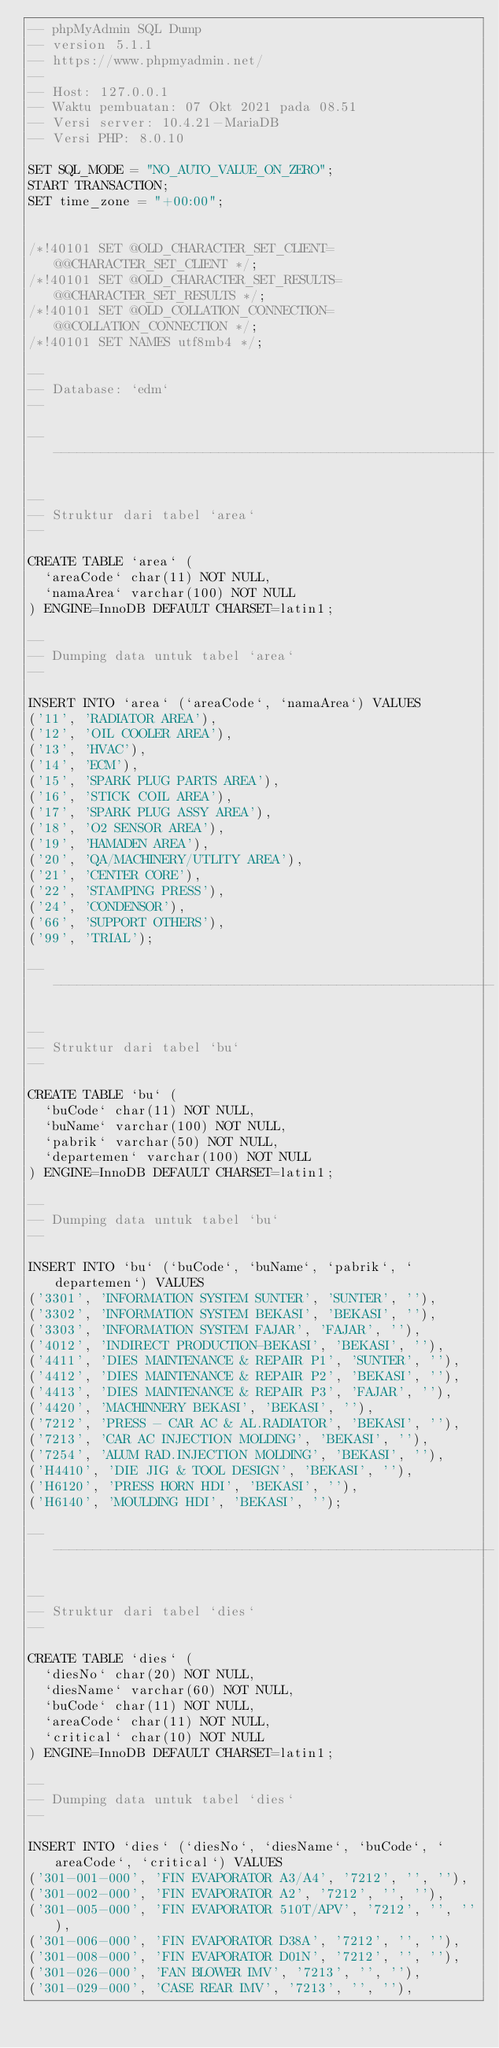<code> <loc_0><loc_0><loc_500><loc_500><_SQL_>-- phpMyAdmin SQL Dump
-- version 5.1.1
-- https://www.phpmyadmin.net/
--
-- Host: 127.0.0.1
-- Waktu pembuatan: 07 Okt 2021 pada 08.51
-- Versi server: 10.4.21-MariaDB
-- Versi PHP: 8.0.10

SET SQL_MODE = "NO_AUTO_VALUE_ON_ZERO";
START TRANSACTION;
SET time_zone = "+00:00";


/*!40101 SET @OLD_CHARACTER_SET_CLIENT=@@CHARACTER_SET_CLIENT */;
/*!40101 SET @OLD_CHARACTER_SET_RESULTS=@@CHARACTER_SET_RESULTS */;
/*!40101 SET @OLD_COLLATION_CONNECTION=@@COLLATION_CONNECTION */;
/*!40101 SET NAMES utf8mb4 */;

--
-- Database: `edm`
--

-- --------------------------------------------------------

--
-- Struktur dari tabel `area`
--

CREATE TABLE `area` (
  `areaCode` char(11) NOT NULL,
  `namaArea` varchar(100) NOT NULL
) ENGINE=InnoDB DEFAULT CHARSET=latin1;

--
-- Dumping data untuk tabel `area`
--

INSERT INTO `area` (`areaCode`, `namaArea`) VALUES
('11', 'RADIATOR AREA'),
('12', 'OIL COOLER AREA'),
('13', 'HVAC'),
('14', 'ECM'),
('15', 'SPARK PLUG PARTS AREA'),
('16', 'STICK COIL AREA'),
('17', 'SPARK PLUG ASSY AREA'),
('18', 'O2 SENSOR AREA'),
('19', 'HAMADEN AREA'),
('20', 'QA/MACHINERY/UTLITY AREA'),
('21', 'CENTER CORE'),
('22', 'STAMPING PRESS'),
('24', 'CONDENSOR'),
('66', 'SUPPORT OTHERS'),
('99', 'TRIAL');

-- --------------------------------------------------------

--
-- Struktur dari tabel `bu`
--

CREATE TABLE `bu` (
  `buCode` char(11) NOT NULL,
  `buName` varchar(100) NOT NULL,
  `pabrik` varchar(50) NOT NULL,
  `departemen` varchar(100) NOT NULL
) ENGINE=InnoDB DEFAULT CHARSET=latin1;

--
-- Dumping data untuk tabel `bu`
--

INSERT INTO `bu` (`buCode`, `buName`, `pabrik`, `departemen`) VALUES
('3301', 'INFORMATION SYSTEM SUNTER', 'SUNTER', ''),
('3302', 'INFORMATION SYSTEM BEKASI', 'BEKASI', ''),
('3303', 'INFORMATION SYSTEM FAJAR', 'FAJAR', ''),
('4012', 'INDIRECT PRODUCTION-BEKASI', 'BEKASI', ''),
('4411', 'DIES MAINTENANCE & REPAIR P1', 'SUNTER', ''),
('4412', 'DIES MAINTENANCE & REPAIR P2', 'BEKASI', ''),
('4413', 'DIES MAINTENANCE & REPAIR P3', 'FAJAR', ''),
('4420', 'MACHINNERY BEKASI', 'BEKASI', ''),
('7212', 'PRESS - CAR AC & AL.RADIATOR', 'BEKASI', ''),
('7213', 'CAR AC INJECTION MOLDING', 'BEKASI', ''),
('7254', 'ALUM RAD.INJECTION MOLDING', 'BEKASI', ''),
('H4410', 'DIE JIG & TOOL DESIGN', 'BEKASI', ''),
('H6120', 'PRESS HORN HDI', 'BEKASI', ''),
('H6140', 'MOULDING HDI', 'BEKASI', '');

-- --------------------------------------------------------

--
-- Struktur dari tabel `dies`
--

CREATE TABLE `dies` (
  `diesNo` char(20) NOT NULL,
  `diesName` varchar(60) NOT NULL,
  `buCode` char(11) NOT NULL,
  `areaCode` char(11) NOT NULL,
  `critical` char(10) NOT NULL
) ENGINE=InnoDB DEFAULT CHARSET=latin1;

--
-- Dumping data untuk tabel `dies`
--

INSERT INTO `dies` (`diesNo`, `diesName`, `buCode`, `areaCode`, `critical`) VALUES
('301-001-000', 'FIN EVAPORATOR A3/A4', '7212', '', ''),
('301-002-000', 'FIN EVAPORATOR A2', '7212', '', ''),
('301-005-000', 'FIN EVAPORATOR 510T/APV', '7212', '', ''),
('301-006-000', 'FIN EVAPORATOR D38A', '7212', '', ''),
('301-008-000', 'FIN EVAPORATOR D01N', '7212', '', ''),
('301-026-000', 'FAN BLOWER IMV', '7213', '', ''),
('301-029-000', 'CASE REAR IMV', '7213', '', ''),</code> 